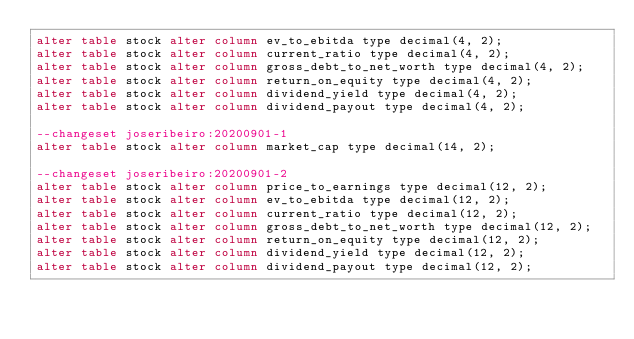<code> <loc_0><loc_0><loc_500><loc_500><_SQL_>alter table stock alter column ev_to_ebitda type decimal(4, 2);
alter table stock alter column current_ratio type decimal(4, 2);
alter table stock alter column gross_debt_to_net_worth type decimal(4, 2);
alter table stock alter column return_on_equity type decimal(4, 2);
alter table stock alter column dividend_yield type decimal(4, 2);
alter table stock alter column dividend_payout type decimal(4, 2);

--changeset joseribeiro:20200901-1
alter table stock alter column market_cap type decimal(14, 2);

--changeset joseribeiro:20200901-2
alter table stock alter column price_to_earnings type decimal(12, 2);
alter table stock alter column ev_to_ebitda type decimal(12, 2);
alter table stock alter column current_ratio type decimal(12, 2);
alter table stock alter column gross_debt_to_net_worth type decimal(12, 2);
alter table stock alter column return_on_equity type decimal(12, 2);
alter table stock alter column dividend_yield type decimal(12, 2);
alter table stock alter column dividend_payout type decimal(12, 2);
</code> 